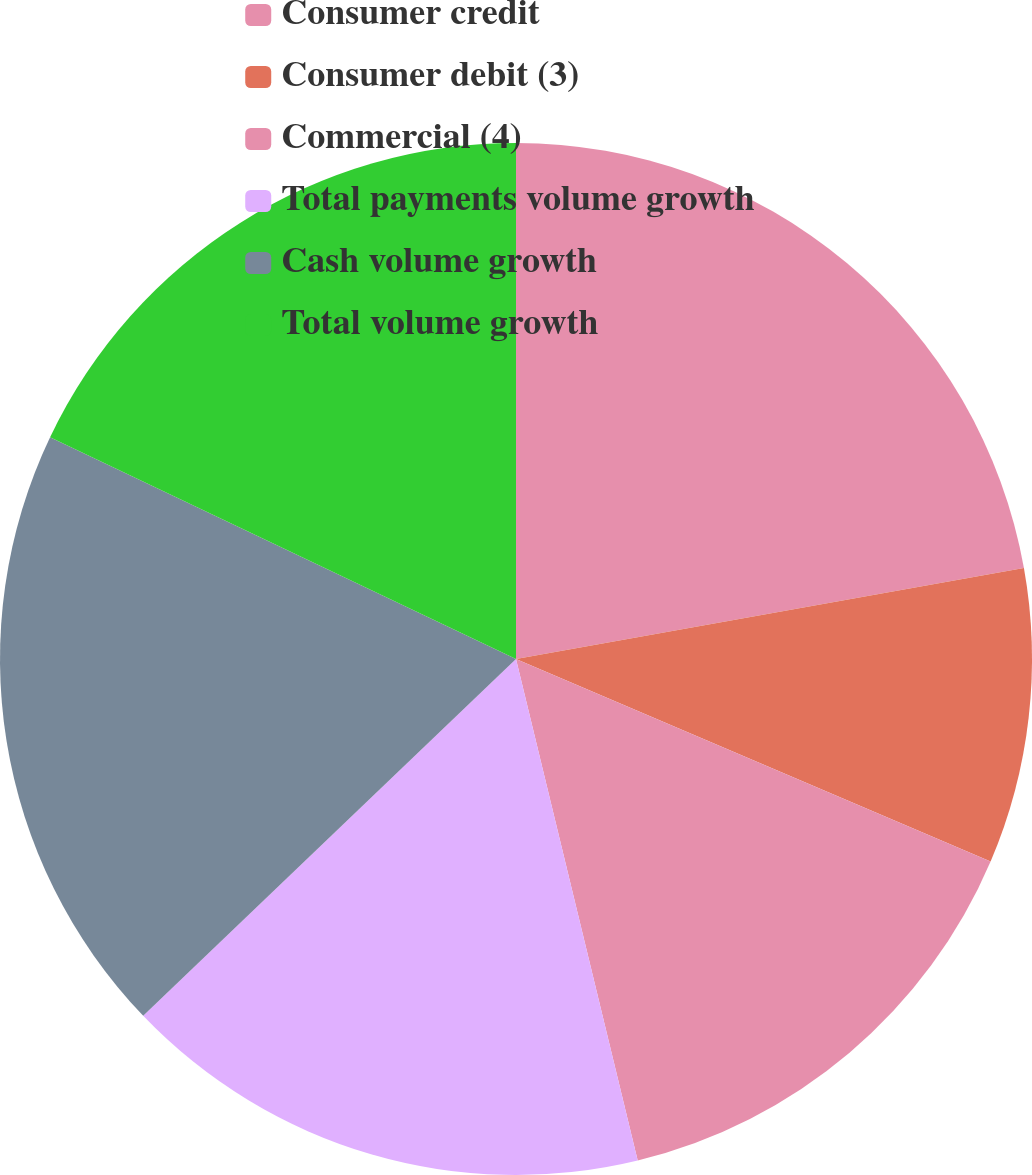Convert chart to OTSL. <chart><loc_0><loc_0><loc_500><loc_500><pie_chart><fcel>Consumer credit<fcel>Consumer debit (3)<fcel>Commercial (4)<fcel>Total payments volume growth<fcel>Cash volume growth<fcel>Total volume growth<nl><fcel>22.18%<fcel>9.24%<fcel>14.79%<fcel>16.64%<fcel>19.22%<fcel>17.93%<nl></chart> 